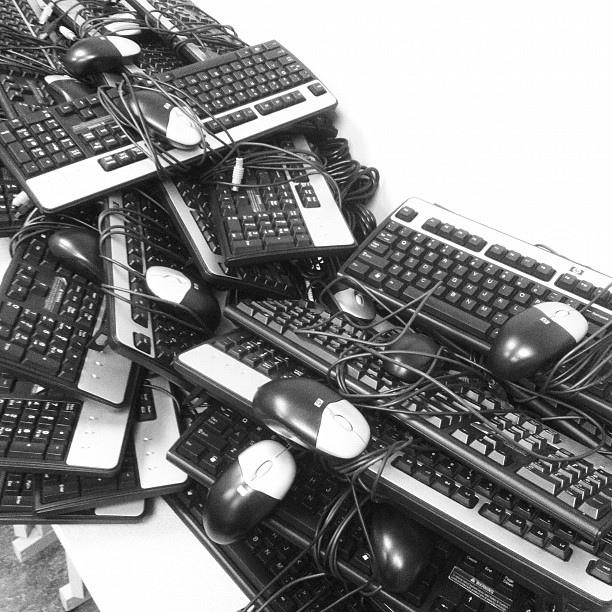Which one of these items would pair well with the items in the photo? Please explain your reasoning. monitor. A pile of keyboards and computer mice are visible. monitors go with keyboards and mice. 